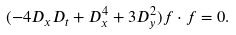<formula> <loc_0><loc_0><loc_500><loc_500>( - 4 D _ { x } D _ { t } + D _ { x } ^ { 4 } + 3 D _ { y } ^ { 2 } ) f \cdot f = 0 .</formula> 